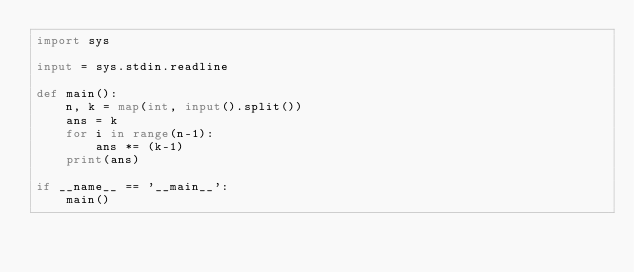<code> <loc_0><loc_0><loc_500><loc_500><_Python_>import sys

input = sys.stdin.readline

def main():
    n, k = map(int, input().split())
    ans = k
    for i in range(n-1):
        ans *= (k-1)
    print(ans)

if __name__ == '__main__':
    main()</code> 